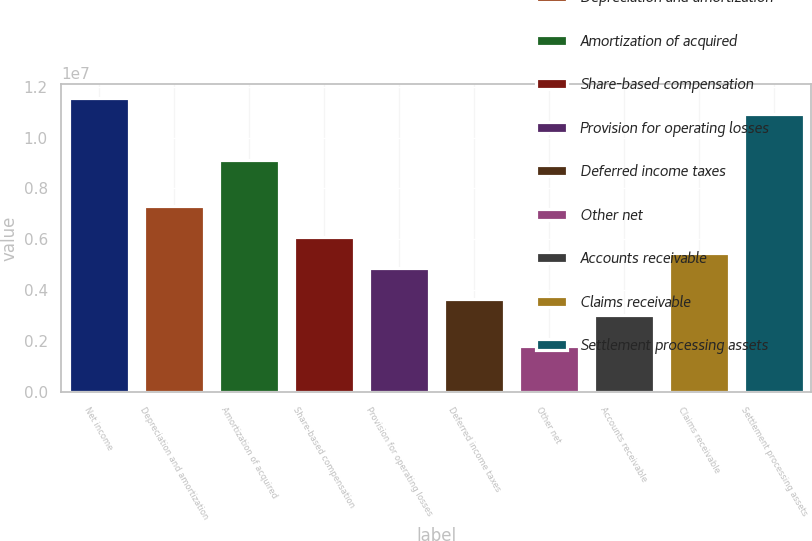Convert chart to OTSL. <chart><loc_0><loc_0><loc_500><loc_500><bar_chart><fcel>Net income<fcel>Depreciation and amortization<fcel>Amortization of acquired<fcel>Share-based compensation<fcel>Provision for operating losses<fcel>Deferred income taxes<fcel>Other net<fcel>Accounts receivable<fcel>Claims receivable<fcel>Settlement processing assets<nl><fcel>1.15437e+07<fcel>7.29279e+06<fcel>9.11463e+06<fcel>6.07823e+06<fcel>4.86367e+06<fcel>3.64911e+06<fcel>1.82728e+06<fcel>3.04183e+06<fcel>5.47095e+06<fcel>1.09365e+07<nl></chart> 